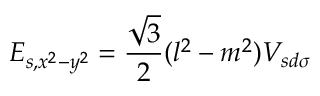Convert formula to latex. <formula><loc_0><loc_0><loc_500><loc_500>E _ { s , x ^ { 2 } - y ^ { 2 } } = { \frac { \sqrt { 3 } } { 2 } } ( l ^ { 2 } - m ^ { 2 } ) V _ { s d \sigma }</formula> 